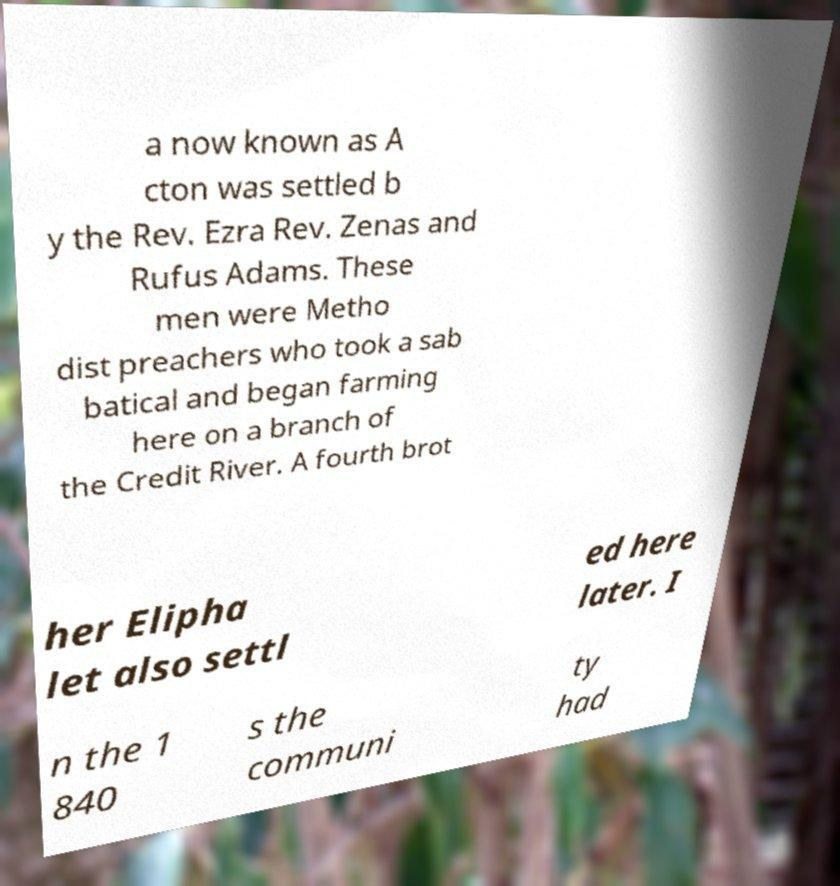Please read and relay the text visible in this image. What does it say? a now known as A cton was settled b y the Rev. Ezra Rev. Zenas and Rufus Adams. These men were Metho dist preachers who took a sab batical and began farming here on a branch of the Credit River. A fourth brot her Elipha let also settl ed here later. I n the 1 840 s the communi ty had 